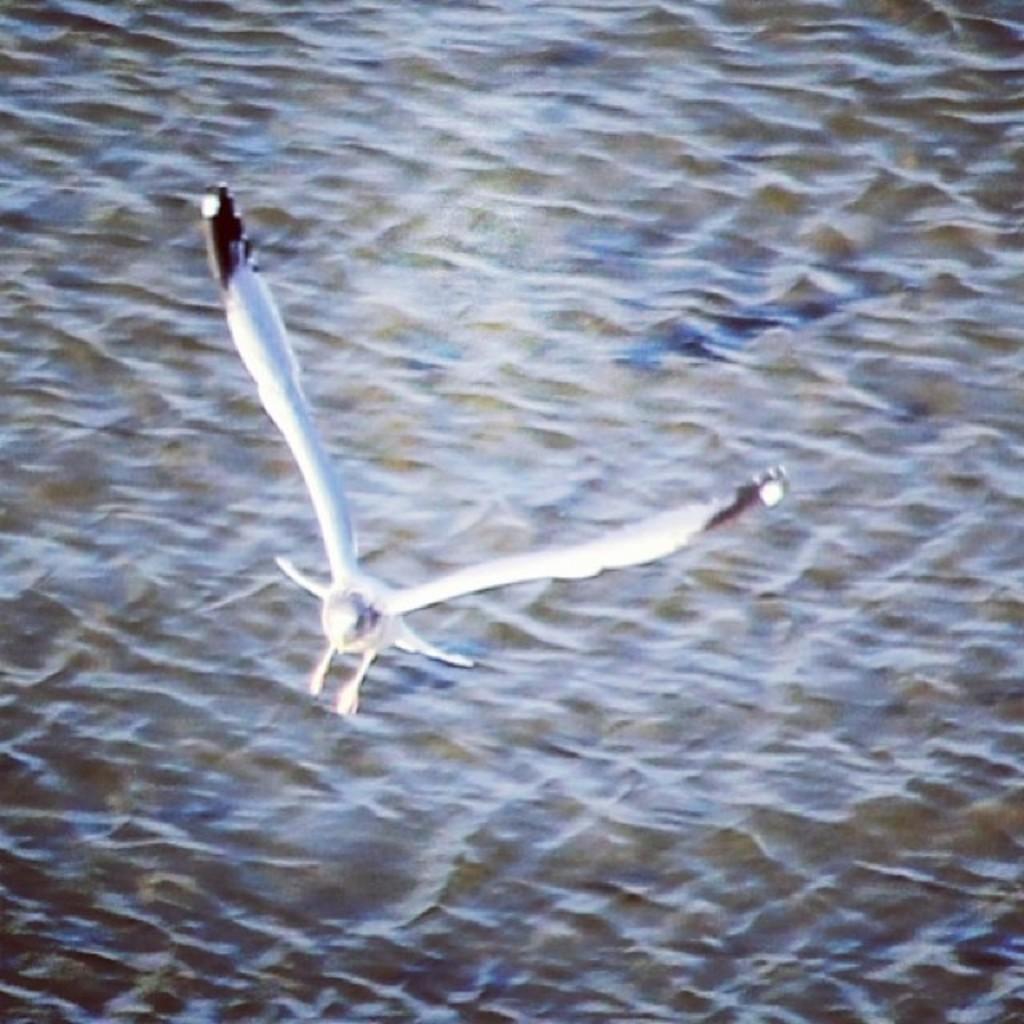Please provide a concise description of this image. In this image we can see a bird flying. On the backside we can see a water body. 